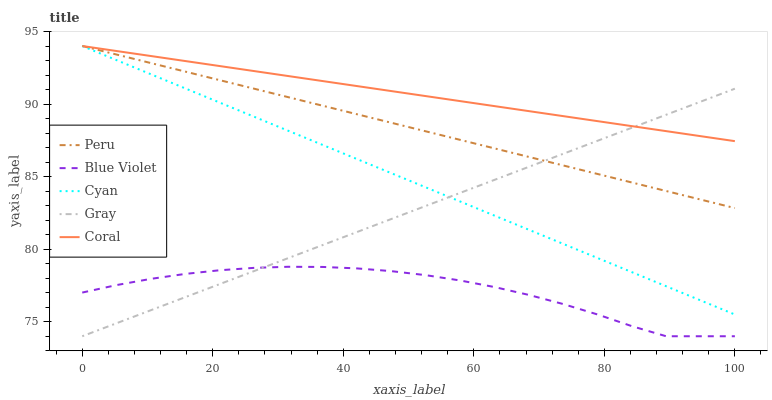Does Blue Violet have the minimum area under the curve?
Answer yes or no. Yes. Does Coral have the maximum area under the curve?
Answer yes or no. Yes. Does Coral have the minimum area under the curve?
Answer yes or no. No. Does Blue Violet have the maximum area under the curve?
Answer yes or no. No. Is Coral the smoothest?
Answer yes or no. Yes. Is Blue Violet the roughest?
Answer yes or no. Yes. Is Blue Violet the smoothest?
Answer yes or no. No. Is Coral the roughest?
Answer yes or no. No. Does Coral have the lowest value?
Answer yes or no. No. Does Peru have the highest value?
Answer yes or no. Yes. Does Blue Violet have the highest value?
Answer yes or no. No. Is Blue Violet less than Cyan?
Answer yes or no. Yes. Is Peru greater than Blue Violet?
Answer yes or no. Yes. Does Coral intersect Peru?
Answer yes or no. Yes. Is Coral less than Peru?
Answer yes or no. No. Is Coral greater than Peru?
Answer yes or no. No. Does Blue Violet intersect Cyan?
Answer yes or no. No. 